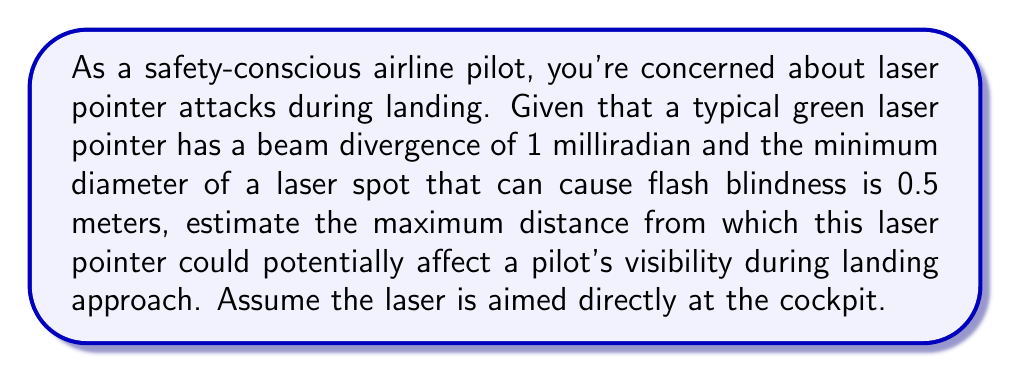Solve this math problem. To solve this problem, we'll use the concept of beam divergence and similar triangles. Let's break it down step-by-step:

1) Beam divergence is the angle at which the laser beam spreads out. In this case, it's given as 1 milliradian (mrad).

2) We need to find the distance at which the laser beam diameter reaches 0.5 meters.

3) Let's define our variables:
   $\theta$ = beam divergence angle (in radians)
   $d$ = diameter of the laser spot
   $R$ = distance from the laser source

4) The relationship between these variables can be expressed as:

   $$\tan(\theta) = \frac{d}{2R}$$

5) For small angles (which 1 mrad is), we can approximate $\tan(\theta) \approx \theta$ when $\theta$ is in radians. So our equation becomes:

   $$\theta = \frac{d}{2R}$$

6) We're given:
   $\theta = 1 \text{ mrad} = 0.001 \text{ rad}$
   $d = 0.5 \text{ m}$

7) Substituting these into our equation:

   $$0.001 = \frac{0.5}{2R}$$

8) Solving for $R$:

   $$R = \frac{0.5}{2 * 0.001} = 250 \text{ m}$$

Therefore, the maximum distance from which this laser pointer could potentially affect a pilot's visibility is approximately 250 meters.
Answer: The maximum distance is approximately 250 meters. 